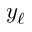<formula> <loc_0><loc_0><loc_500><loc_500>y _ { \ell }</formula> 